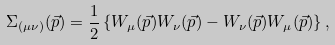Convert formula to latex. <formula><loc_0><loc_0><loc_500><loc_500>\Sigma _ { ( \mu \nu ) } ( \vec { p } ) = \frac { 1 } { 2 } \left \{ W _ { \mu } ( \vec { p } ) W _ { \nu } ( \vec { p } ) - W _ { \nu } ( \vec { p } ) W _ { \mu } ( \vec { p } ) \right \} ,</formula> 